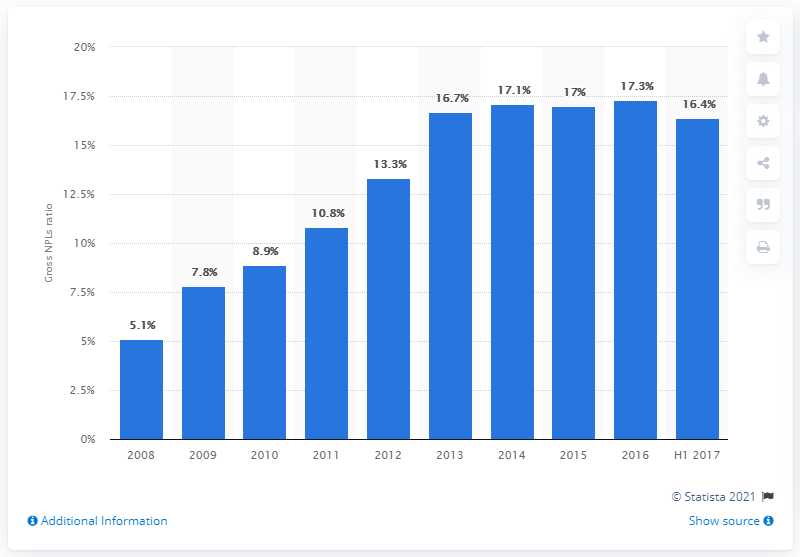Point out several critical features in this image. According to the data from the first semester of 2017, a significant portion, approximately 16.4%, of Italian loans were classified as non-performing. 